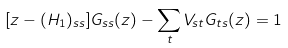<formula> <loc_0><loc_0><loc_500><loc_500>[ z - ( H _ { 1 } ) _ { s s } ] G _ { s s } ( z ) - \sum _ { t } V _ { s t } G _ { t s } ( z ) = 1</formula> 